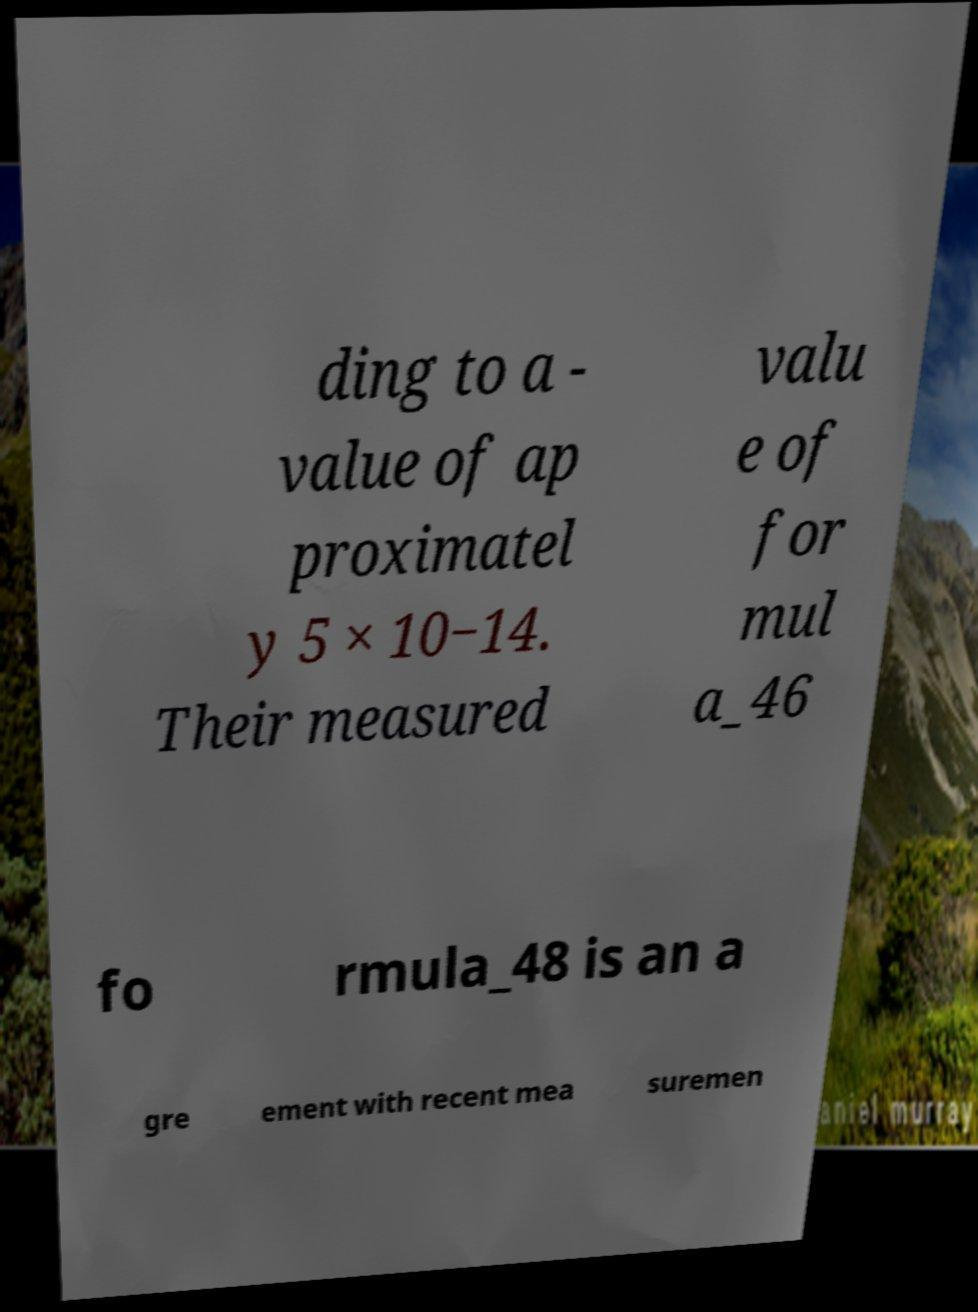Could you extract and type out the text from this image? ding to a - value of ap proximatel y 5 × 10−14. Their measured valu e of for mul a_46 fo rmula_48 is an a gre ement with recent mea suremen 